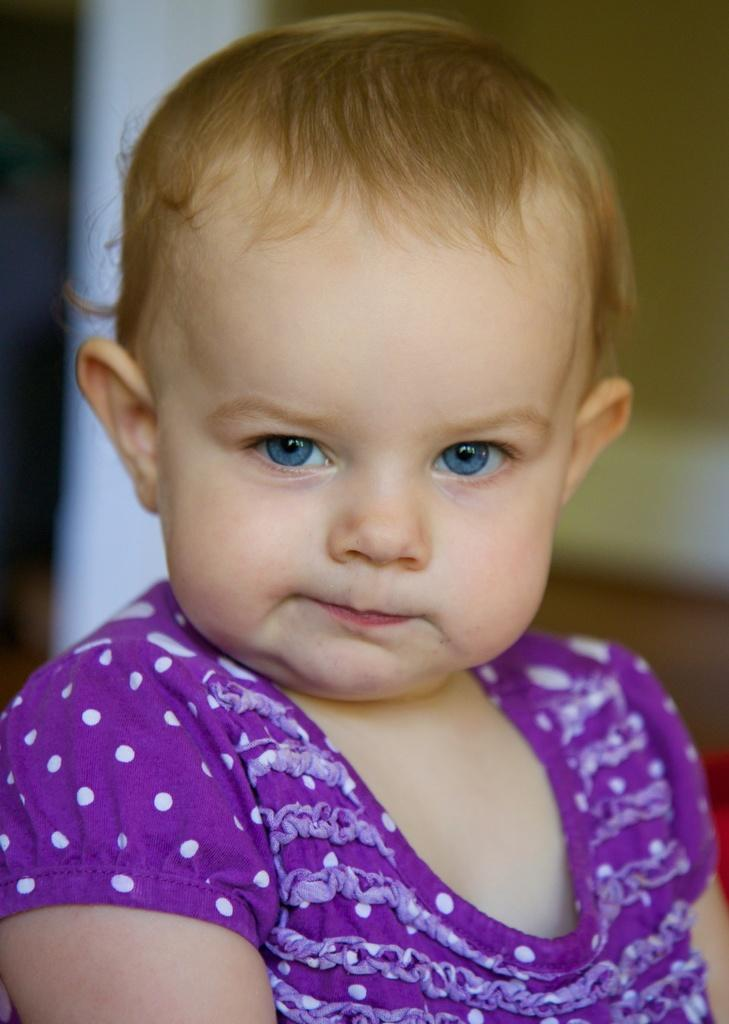What is the main subject of the image? There is a baby in the image. Can you describe what the baby is wearing? The baby is wearing a thick pink dress. How would you describe the background of the image? The background of the image is blurred. How many basketballs can be seen in the image? There are no basketballs present in the image. What type of hole is visible in the image? There is no hole visible in the image. 